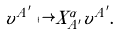Convert formula to latex. <formula><loc_0><loc_0><loc_500><loc_500>v ^ { A ^ { \prime } } \mapsto X ^ { \alpha } _ { A ^ { \prime } } v ^ { A ^ { \prime } } .</formula> 